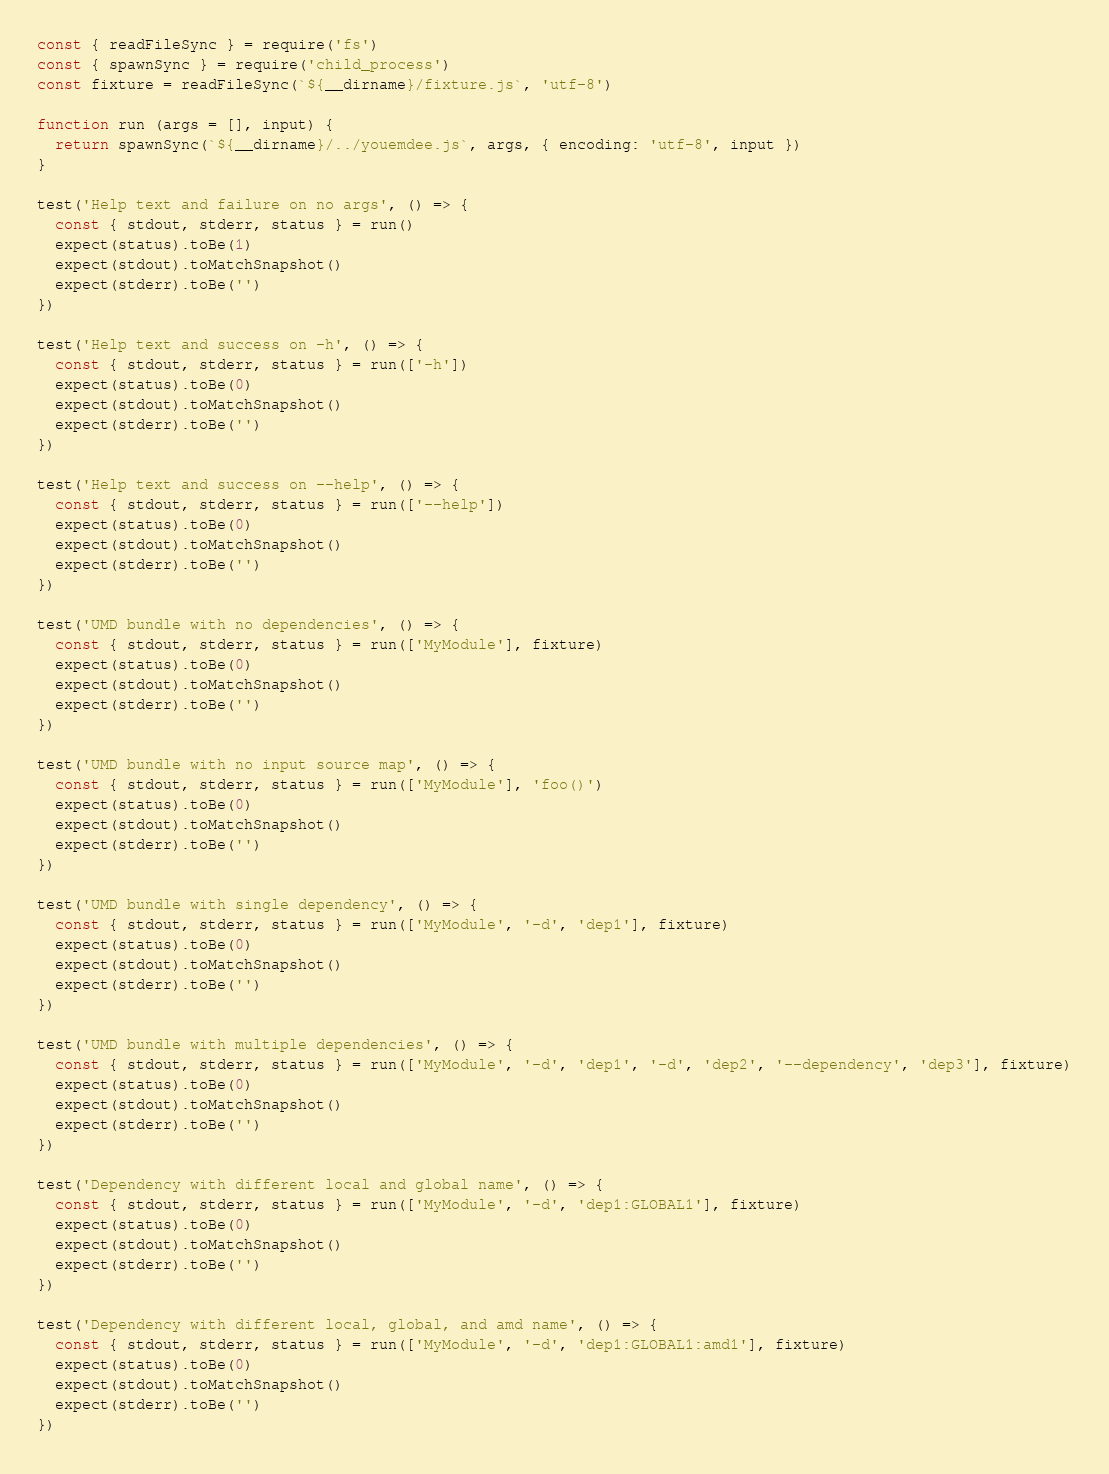Convert code to text. <code><loc_0><loc_0><loc_500><loc_500><_JavaScript_>const { readFileSync } = require('fs')
const { spawnSync } = require('child_process')
const fixture = readFileSync(`${__dirname}/fixture.js`, 'utf-8')

function run (args = [], input) {
  return spawnSync(`${__dirname}/../youemdee.js`, args, { encoding: 'utf-8', input })
}

test('Help text and failure on no args', () => {
  const { stdout, stderr, status } = run()
  expect(status).toBe(1)
  expect(stdout).toMatchSnapshot()
  expect(stderr).toBe('')
})

test('Help text and success on -h', () => {
  const { stdout, stderr, status } = run(['-h'])
  expect(status).toBe(0)
  expect(stdout).toMatchSnapshot()
  expect(stderr).toBe('')
})

test('Help text and success on --help', () => {
  const { stdout, stderr, status } = run(['--help'])
  expect(status).toBe(0)
  expect(stdout).toMatchSnapshot()
  expect(stderr).toBe('')
})

test('UMD bundle with no dependencies', () => {
  const { stdout, stderr, status } = run(['MyModule'], fixture)
  expect(status).toBe(0)
  expect(stdout).toMatchSnapshot()
  expect(stderr).toBe('')
})

test('UMD bundle with no input source map', () => {
  const { stdout, stderr, status } = run(['MyModule'], 'foo()')
  expect(status).toBe(0)
  expect(stdout).toMatchSnapshot()
  expect(stderr).toBe('')
})

test('UMD bundle with single dependency', () => {
  const { stdout, stderr, status } = run(['MyModule', '-d', 'dep1'], fixture)
  expect(status).toBe(0)
  expect(stdout).toMatchSnapshot()
  expect(stderr).toBe('')
})

test('UMD bundle with multiple dependencies', () => {
  const { stdout, stderr, status } = run(['MyModule', '-d', 'dep1', '-d', 'dep2', '--dependency', 'dep3'], fixture)
  expect(status).toBe(0)
  expect(stdout).toMatchSnapshot()
  expect(stderr).toBe('')
})

test('Dependency with different local and global name', () => {
  const { stdout, stderr, status } = run(['MyModule', '-d', 'dep1:GLOBAL1'], fixture)
  expect(status).toBe(0)
  expect(stdout).toMatchSnapshot()
  expect(stderr).toBe('')
})

test('Dependency with different local, global, and amd name', () => {
  const { stdout, stderr, status } = run(['MyModule', '-d', 'dep1:GLOBAL1:amd1'], fixture)
  expect(status).toBe(0)
  expect(stdout).toMatchSnapshot()
  expect(stderr).toBe('')
})
</code> 